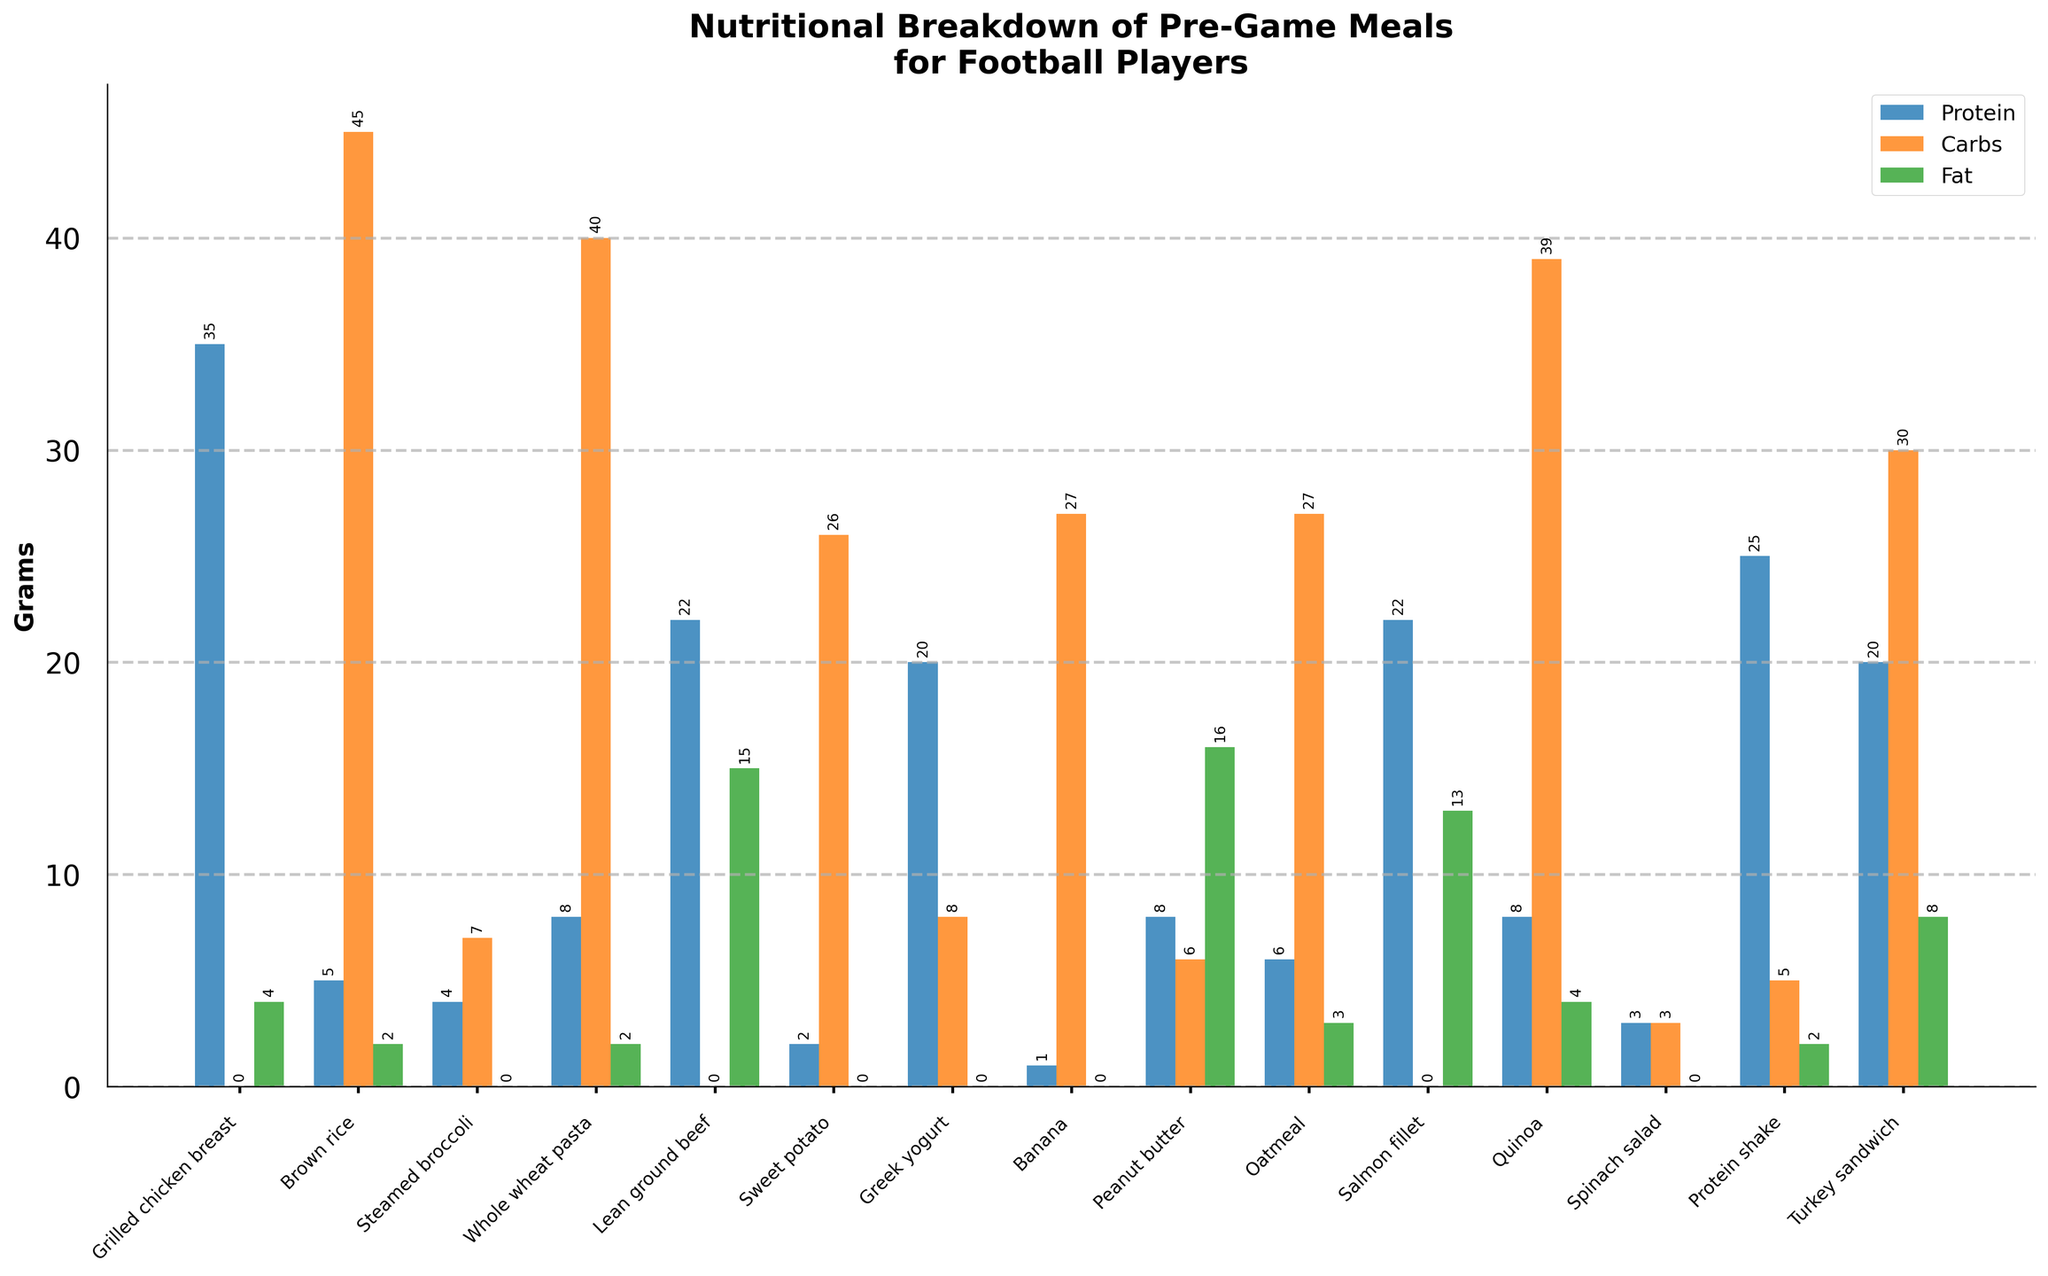what is the total amount of protein in Grilled chicken breast and Turkey sandwich combined? Add the protein amounts for Grilled chicken breast (35g) and Turkey sandwich (20g): 35 + 20 = 55
Answer: 55g Which food item has the highest amount of carbs? Look at the Carb bars across the items and identify the tallest bar representing carbs. Banana has the highest amount with 27g of carbs.
Answer: Banana Does Quinoa have more carbs or protein? Compare the height of the carb and protein bars for Quinoa. The carb bar is higher than the protein bar, indicating Quinoa has more carbs (39g) than protein (8g).
Answer: Carbs Which item contains the least amount of fat? Identify the food item with the shortest fat bar in the chart. Steamed broccoli, Sweet potato, Greek yogurt, Banana, Spinach salad all have 0 grams of fat, but let's take the first one listed.
Answer: Steamed broccoli How many grams of carbs does Brown rice have more than Whole wheat pasta? Find the difference in carb grams between Brown rice (45g) and Whole wheat pasta (40g): 45 - 40 = 5
Answer: 5g What is the total number of fat grams in Lean ground beef and Salmon fillet combined? Sum the fat grams for Lean ground beef (15g) and Salmon fillet (13g): 15 + 13 = 28
Answer: 28g Which food items contain exactly 20 grams of protein each? Check the protein bars for the foods with a value of 20 grams. Greek yogurt and Turkey sandwich both have 20 grams of protein.
Answer: Greek yogurt, Turkey sandwich What is the difference in carb content between Oatmeal and Spinach salad? Calculate the difference in carbohydrates between Oatmeal (27g) and Spinach salad (3g): 27 - 3 = 24
Answer: 24g Which food item has more fat: Peanut butter or Protein shake? Compare the heights of the fat bars for Peanut butter and Protein shake. The fat bar for Peanut butter is higher (16g) than that for Protein shake (2g).
Answer: Peanut butter 